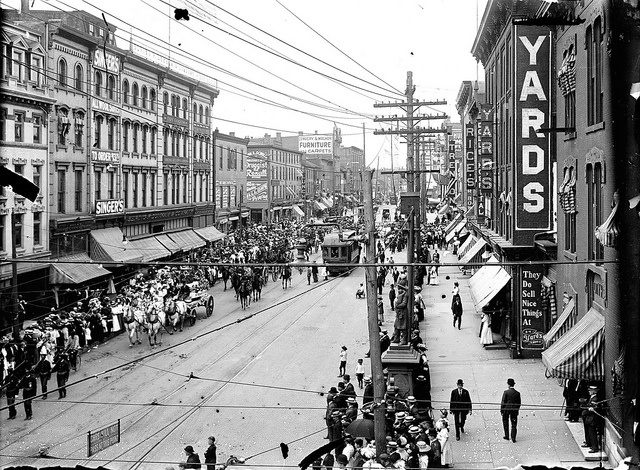Describe the objects in this image and their specific colors. I can see people in darkgray, black, gray, and gainsboro tones, train in darkgray, black, gray, and lightgray tones, bus in darkgray, black, gray, and lightgray tones, people in darkgray, black, gray, and lightgray tones, and people in darkgray, black, gray, and lightgray tones in this image. 